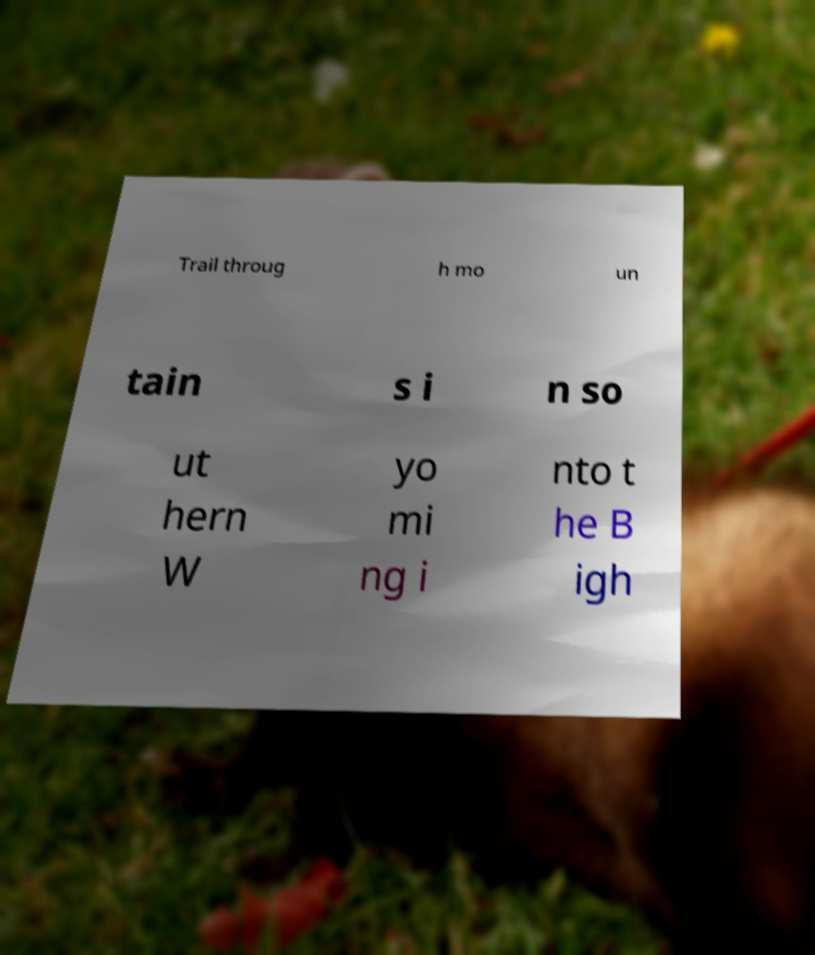Could you assist in decoding the text presented in this image and type it out clearly? Trail throug h mo un tain s i n so ut hern W yo mi ng i nto t he B igh 